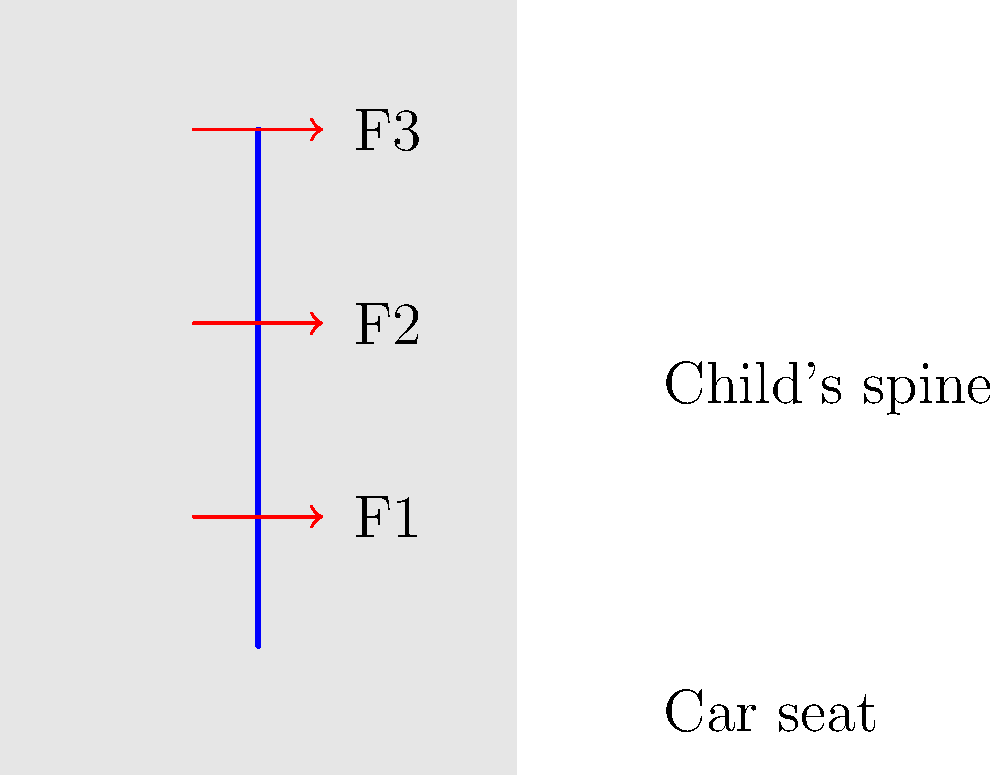In the diagram above, which represents a child seated in a car seat, three forces (F1, F2, and F3) are shown acting on the child's spine. How does the distribution of these forces typically change when comparing a rear-facing car seat to a forward-facing car seat for a toddler? To understand the force distribution on a child's spine in different car seat orientations, we need to consider the following steps:

1. Rear-facing car seats:
   - Distribute the force more evenly along the child's back and spine
   - Reduce the stress on any single point of the spine
   - Support the head, neck, and spine in the event of a crash

2. Forward-facing car seats:
   - Concentrate more force on the child's neck and upper spine
   - May cause more stress on specific points of the spine
   - Provide less support for the head and neck in a crash

3. Force distribution comparison:
   - In a rear-facing seat:
     F1 ≈ F2 ≈ F3 (forces are more evenly distributed)
   - In a forward-facing seat:
     F3 > F2 > F1 (more force on the upper spine and neck)

4. Biomechanical implications:
   - Rear-facing seats reduce the risk of spinal cord injuries
   - Forward-facing seats may increase the risk of head and neck injuries, especially in young children

5. Recommendations:
   - Keep children in rear-facing seats for as long as possible (usually until age 2-4, depending on the seat's weight limit)
   - Transition to forward-facing seats only when the child outgrows the rear-facing seat's height or weight limit

The force distribution in rear-facing seats is more favorable for protecting a child's developing spine and neck, especially in the event of a sudden stop or collision.
Answer: Rear-facing seats distribute forces more evenly (F1 ≈ F2 ≈ F3), while forward-facing seats concentrate forces on the upper spine (F3 > F2 > F1). 